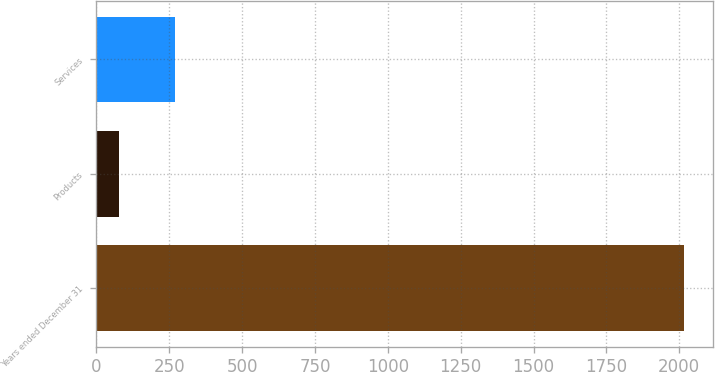<chart> <loc_0><loc_0><loc_500><loc_500><bar_chart><fcel>Years ended December 31<fcel>Products<fcel>Services<nl><fcel>2015<fcel>76<fcel>269.9<nl></chart> 